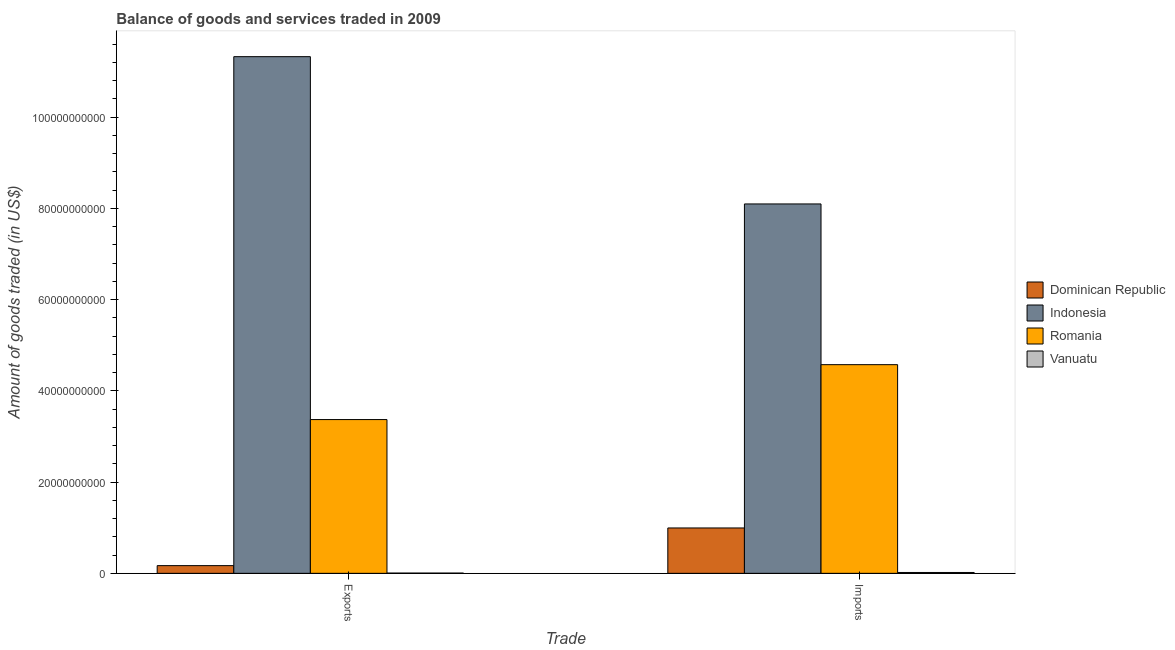How many different coloured bars are there?
Your answer should be compact. 4. Are the number of bars per tick equal to the number of legend labels?
Your response must be concise. Yes. What is the label of the 1st group of bars from the left?
Keep it short and to the point. Exports. What is the amount of goods exported in Indonesia?
Make the answer very short. 1.13e+11. Across all countries, what is the maximum amount of goods exported?
Your answer should be compact. 1.13e+11. Across all countries, what is the minimum amount of goods exported?
Your response must be concise. 5.52e+07. In which country was the amount of goods exported maximum?
Provide a succinct answer. Indonesia. In which country was the amount of goods exported minimum?
Keep it short and to the point. Vanuatu. What is the total amount of goods imported in the graph?
Make the answer very short. 1.37e+11. What is the difference between the amount of goods imported in Vanuatu and that in Dominican Republic?
Keep it short and to the point. -9.76e+09. What is the difference between the amount of goods imported in Vanuatu and the amount of goods exported in Indonesia?
Your answer should be compact. -1.13e+11. What is the average amount of goods exported per country?
Keep it short and to the point. 3.72e+1. What is the difference between the amount of goods exported and amount of goods imported in Dominican Republic?
Offer a very short reply. -8.26e+09. What is the ratio of the amount of goods imported in Romania to that in Dominican Republic?
Your answer should be compact. 4.6. Is the amount of goods imported in Vanuatu less than that in Dominican Republic?
Offer a terse response. Yes. In how many countries, is the amount of goods exported greater than the average amount of goods exported taken over all countries?
Provide a succinct answer. 1. What does the 4th bar from the left in Imports represents?
Your answer should be very brief. Vanuatu. What does the 1st bar from the right in Imports represents?
Provide a succinct answer. Vanuatu. How many bars are there?
Keep it short and to the point. 8. Are all the bars in the graph horizontal?
Offer a very short reply. No. What is the difference between two consecutive major ticks on the Y-axis?
Your answer should be compact. 2.00e+1. Does the graph contain grids?
Give a very brief answer. No. Where does the legend appear in the graph?
Give a very brief answer. Center right. How are the legend labels stacked?
Provide a succinct answer. Vertical. What is the title of the graph?
Offer a terse response. Balance of goods and services traded in 2009. Does "Korea (Democratic)" appear as one of the legend labels in the graph?
Keep it short and to the point. No. What is the label or title of the X-axis?
Keep it short and to the point. Trade. What is the label or title of the Y-axis?
Offer a very short reply. Amount of goods traded (in US$). What is the Amount of goods traded (in US$) in Dominican Republic in Exports?
Ensure brevity in your answer.  1.69e+09. What is the Amount of goods traded (in US$) of Indonesia in Exports?
Your answer should be very brief. 1.13e+11. What is the Amount of goods traded (in US$) in Romania in Exports?
Your response must be concise. 3.37e+1. What is the Amount of goods traded (in US$) of Vanuatu in Exports?
Make the answer very short. 5.52e+07. What is the Amount of goods traded (in US$) in Dominican Republic in Imports?
Keep it short and to the point. 9.95e+09. What is the Amount of goods traded (in US$) of Indonesia in Imports?
Offer a terse response. 8.10e+1. What is the Amount of goods traded (in US$) of Romania in Imports?
Offer a very short reply. 4.57e+1. What is the Amount of goods traded (in US$) in Vanuatu in Imports?
Keep it short and to the point. 1.87e+08. Across all Trade, what is the maximum Amount of goods traded (in US$) in Dominican Republic?
Provide a succinct answer. 9.95e+09. Across all Trade, what is the maximum Amount of goods traded (in US$) of Indonesia?
Provide a succinct answer. 1.13e+11. Across all Trade, what is the maximum Amount of goods traded (in US$) in Romania?
Offer a very short reply. 4.57e+1. Across all Trade, what is the maximum Amount of goods traded (in US$) in Vanuatu?
Make the answer very short. 1.87e+08. Across all Trade, what is the minimum Amount of goods traded (in US$) in Dominican Republic?
Make the answer very short. 1.69e+09. Across all Trade, what is the minimum Amount of goods traded (in US$) in Indonesia?
Offer a very short reply. 8.10e+1. Across all Trade, what is the minimum Amount of goods traded (in US$) of Romania?
Offer a very short reply. 3.37e+1. Across all Trade, what is the minimum Amount of goods traded (in US$) in Vanuatu?
Provide a succinct answer. 5.52e+07. What is the total Amount of goods traded (in US$) of Dominican Republic in the graph?
Give a very brief answer. 1.16e+1. What is the total Amount of goods traded (in US$) of Indonesia in the graph?
Your answer should be compact. 1.94e+11. What is the total Amount of goods traded (in US$) of Romania in the graph?
Keep it short and to the point. 7.95e+1. What is the total Amount of goods traded (in US$) in Vanuatu in the graph?
Give a very brief answer. 2.42e+08. What is the difference between the Amount of goods traded (in US$) in Dominican Republic in Exports and that in Imports?
Offer a terse response. -8.26e+09. What is the difference between the Amount of goods traded (in US$) in Indonesia in Exports and that in Imports?
Offer a very short reply. 3.23e+1. What is the difference between the Amount of goods traded (in US$) in Romania in Exports and that in Imports?
Your answer should be very brief. -1.20e+1. What is the difference between the Amount of goods traded (in US$) of Vanuatu in Exports and that in Imports?
Offer a very short reply. -1.32e+08. What is the difference between the Amount of goods traded (in US$) of Dominican Republic in Exports and the Amount of goods traded (in US$) of Indonesia in Imports?
Provide a short and direct response. -7.93e+1. What is the difference between the Amount of goods traded (in US$) of Dominican Republic in Exports and the Amount of goods traded (in US$) of Romania in Imports?
Your answer should be compact. -4.41e+1. What is the difference between the Amount of goods traded (in US$) of Dominican Republic in Exports and the Amount of goods traded (in US$) of Vanuatu in Imports?
Offer a very short reply. 1.50e+09. What is the difference between the Amount of goods traded (in US$) of Indonesia in Exports and the Amount of goods traded (in US$) of Romania in Imports?
Your response must be concise. 6.75e+1. What is the difference between the Amount of goods traded (in US$) in Indonesia in Exports and the Amount of goods traded (in US$) in Vanuatu in Imports?
Provide a short and direct response. 1.13e+11. What is the difference between the Amount of goods traded (in US$) of Romania in Exports and the Amount of goods traded (in US$) of Vanuatu in Imports?
Provide a succinct answer. 3.35e+1. What is the average Amount of goods traded (in US$) in Dominican Republic per Trade?
Keep it short and to the point. 5.82e+09. What is the average Amount of goods traded (in US$) of Indonesia per Trade?
Provide a succinct answer. 9.71e+1. What is the average Amount of goods traded (in US$) of Romania per Trade?
Provide a succinct answer. 3.97e+1. What is the average Amount of goods traded (in US$) in Vanuatu per Trade?
Make the answer very short. 1.21e+08. What is the difference between the Amount of goods traded (in US$) in Dominican Republic and Amount of goods traded (in US$) in Indonesia in Exports?
Ensure brevity in your answer.  -1.12e+11. What is the difference between the Amount of goods traded (in US$) in Dominican Republic and Amount of goods traded (in US$) in Romania in Exports?
Your response must be concise. -3.20e+1. What is the difference between the Amount of goods traded (in US$) in Dominican Republic and Amount of goods traded (in US$) in Vanuatu in Exports?
Offer a very short reply. 1.63e+09. What is the difference between the Amount of goods traded (in US$) of Indonesia and Amount of goods traded (in US$) of Romania in Exports?
Your answer should be compact. 7.96e+1. What is the difference between the Amount of goods traded (in US$) in Indonesia and Amount of goods traded (in US$) in Vanuatu in Exports?
Offer a very short reply. 1.13e+11. What is the difference between the Amount of goods traded (in US$) of Romania and Amount of goods traded (in US$) of Vanuatu in Exports?
Offer a terse response. 3.37e+1. What is the difference between the Amount of goods traded (in US$) of Dominican Republic and Amount of goods traded (in US$) of Indonesia in Imports?
Your answer should be compact. -7.10e+1. What is the difference between the Amount of goods traded (in US$) in Dominican Republic and Amount of goods traded (in US$) in Romania in Imports?
Keep it short and to the point. -3.58e+1. What is the difference between the Amount of goods traded (in US$) of Dominican Republic and Amount of goods traded (in US$) of Vanuatu in Imports?
Give a very brief answer. 9.76e+09. What is the difference between the Amount of goods traded (in US$) in Indonesia and Amount of goods traded (in US$) in Romania in Imports?
Ensure brevity in your answer.  3.52e+1. What is the difference between the Amount of goods traded (in US$) of Indonesia and Amount of goods traded (in US$) of Vanuatu in Imports?
Give a very brief answer. 8.08e+1. What is the difference between the Amount of goods traded (in US$) in Romania and Amount of goods traded (in US$) in Vanuatu in Imports?
Keep it short and to the point. 4.56e+1. What is the ratio of the Amount of goods traded (in US$) in Dominican Republic in Exports to that in Imports?
Your answer should be compact. 0.17. What is the ratio of the Amount of goods traded (in US$) of Indonesia in Exports to that in Imports?
Make the answer very short. 1.4. What is the ratio of the Amount of goods traded (in US$) in Romania in Exports to that in Imports?
Give a very brief answer. 0.74. What is the ratio of the Amount of goods traded (in US$) in Vanuatu in Exports to that in Imports?
Your answer should be compact. 0.3. What is the difference between the highest and the second highest Amount of goods traded (in US$) of Dominican Republic?
Offer a terse response. 8.26e+09. What is the difference between the highest and the second highest Amount of goods traded (in US$) of Indonesia?
Keep it short and to the point. 3.23e+1. What is the difference between the highest and the second highest Amount of goods traded (in US$) in Romania?
Your response must be concise. 1.20e+1. What is the difference between the highest and the second highest Amount of goods traded (in US$) of Vanuatu?
Offer a very short reply. 1.32e+08. What is the difference between the highest and the lowest Amount of goods traded (in US$) of Dominican Republic?
Give a very brief answer. 8.26e+09. What is the difference between the highest and the lowest Amount of goods traded (in US$) in Indonesia?
Make the answer very short. 3.23e+1. What is the difference between the highest and the lowest Amount of goods traded (in US$) of Romania?
Ensure brevity in your answer.  1.20e+1. What is the difference between the highest and the lowest Amount of goods traded (in US$) of Vanuatu?
Offer a terse response. 1.32e+08. 